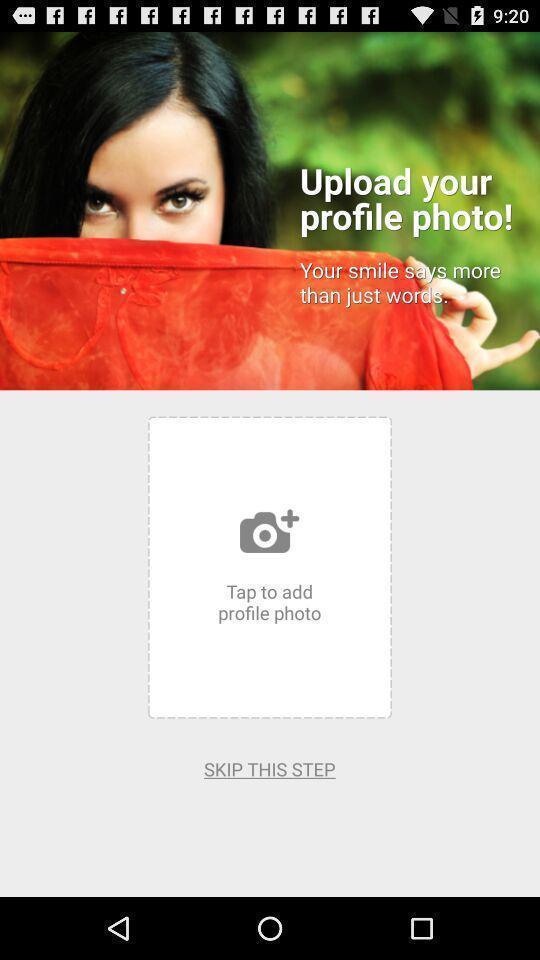What details can you identify in this image? Upload profile photo in the profile. 